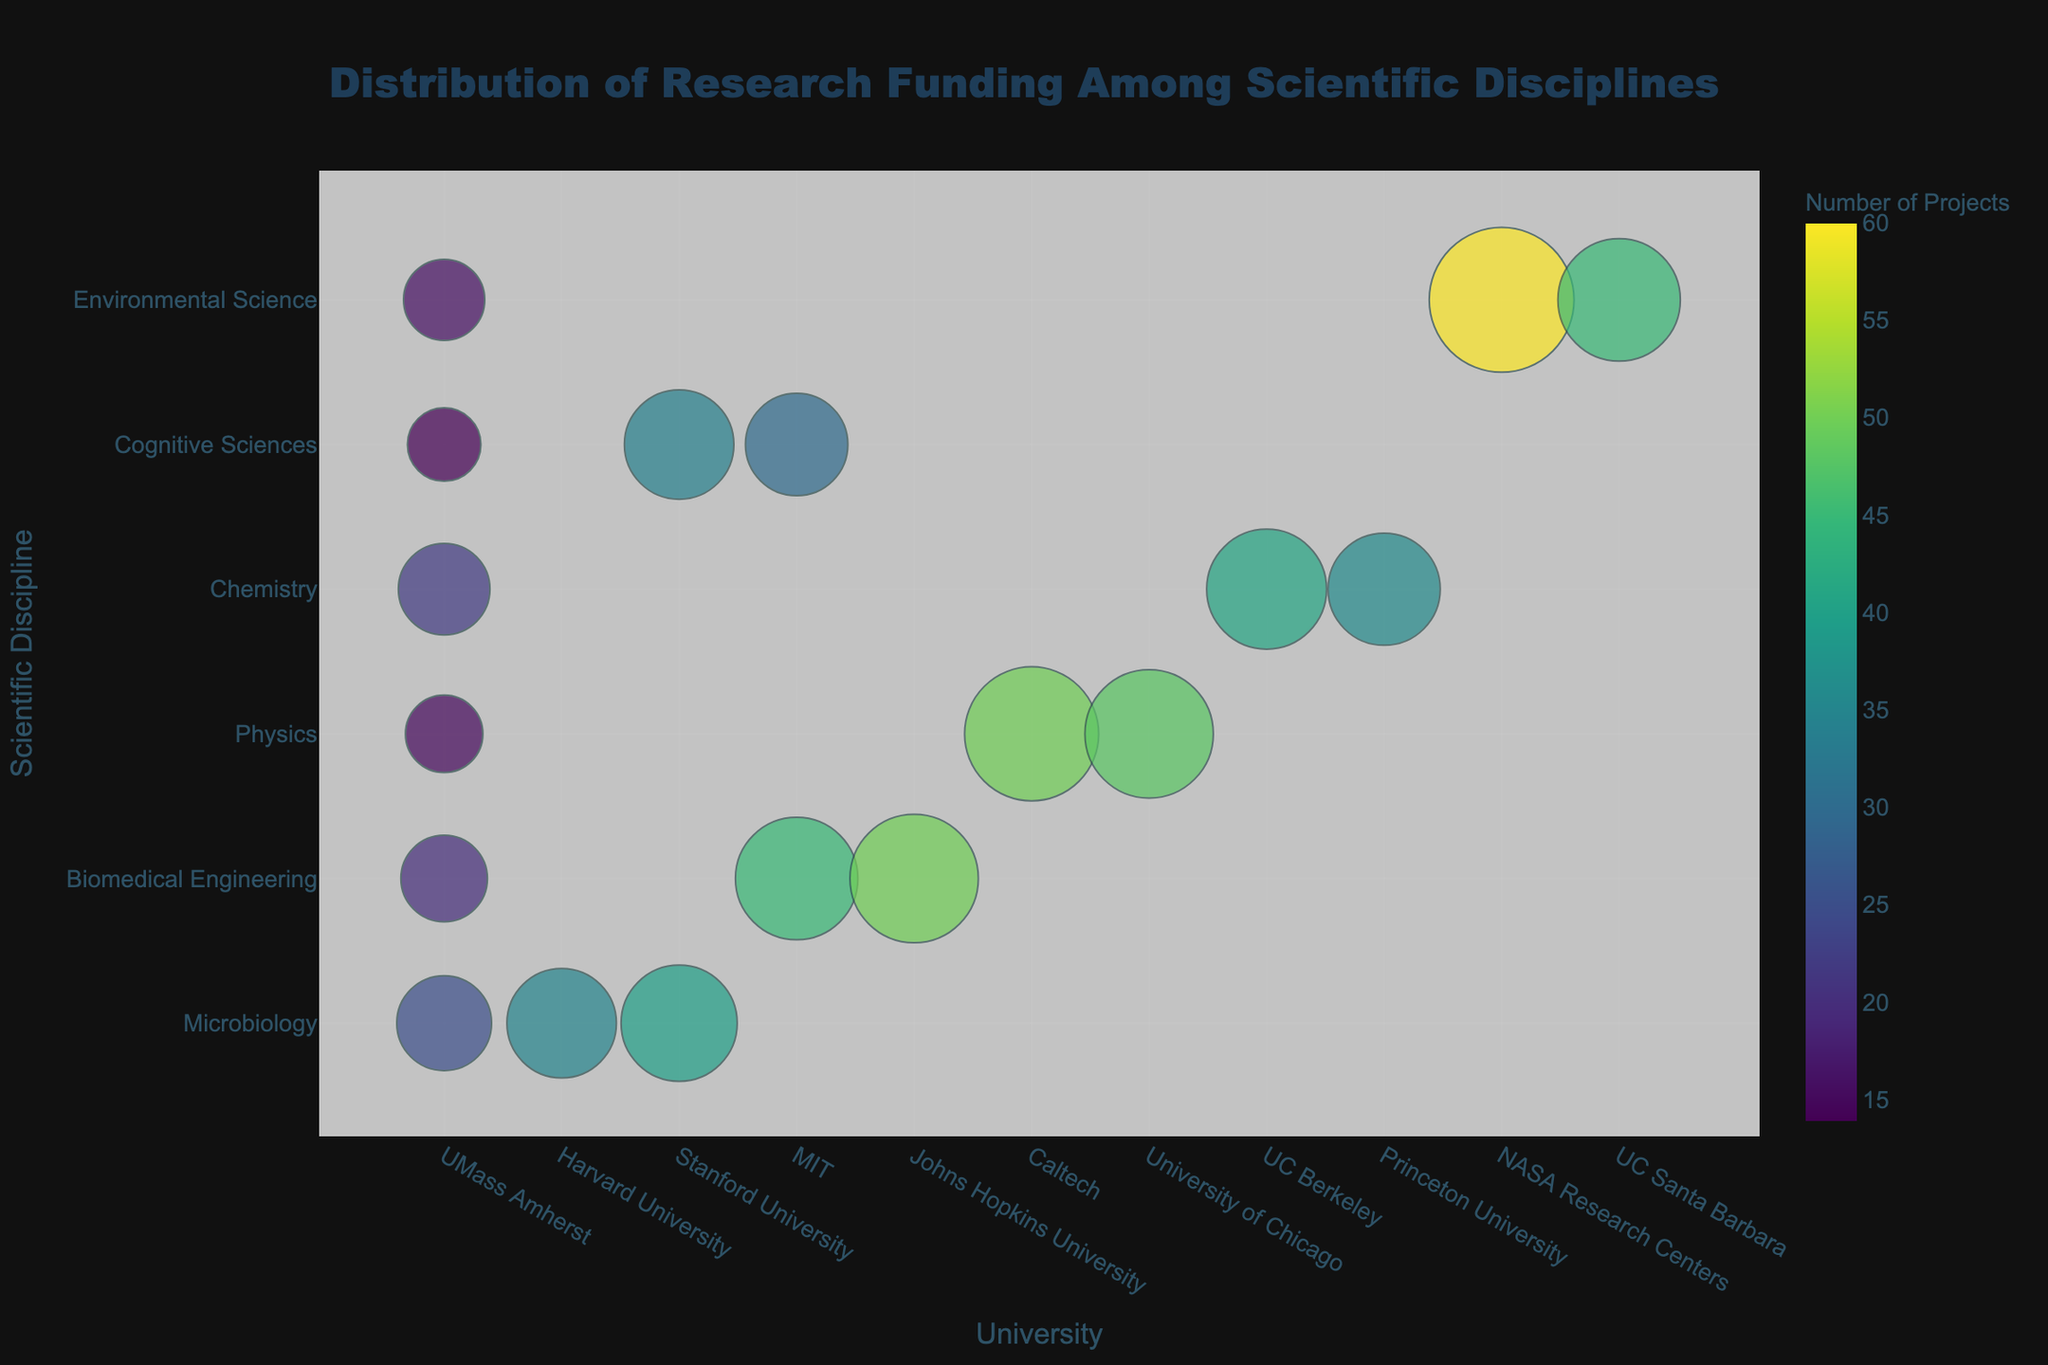Which university has the highest research funding in the Environmental Science discipline? By looking at the bubbles sorted by size in the Environmental Science row, the largest bubble corresponds to NASA Research Centers, indicating the highest funding.
Answer: NASA Research Centers Which discipline has the smallest total number of projects at UMass Amherst? To find this, add up the number of projects for each discipline at UMass Amherst: Microbiology (25), Biomedical Engineering (20), Physics (15), Chemistry (22), Cognitive Sciences (14), and Environmental Science (16). The smallest number is 14 in Cognitive Sciences.
Answer: Cognitive Sciences Among the universities listed, which one has the highest number of projects in the Physics discipline? By looking at the Physics row and comparing the "Number of Projects" colors, Caltech has the bubble with the darkest shade, indicating the highest number of projects.
Answer: Caltech Which university receives a noticeably larger amount of funding for Chemistry compared to other universities? By comparing the bubble sizes in the Chemistry row, UC Berkeley has a larger bubble size compared to Princeton University and UMass Amherst, indicating higher funding.
Answer: UC Berkeley How does the research funding for Microbiology at Stanford University compare to Harvard University? Compare the size of the bubbles for Microbiology at Stanford University and Harvard University. Stanford University has a slightly larger bubble (45 million) compared to Harvard University (40 million), indicating higher funding.
Answer: Stanford University has higher funding What's the average amount of research funding for Biomedical Engineering across the universities listed? Sum the funding amounts: UMass Amherst (25 million), MIT (50 million), and Johns Hopkins University (55 million). Then divide by the number of universities: (25 + 50 + 55) / 3 = 130 / 3 = ~43.33 million.
Answer: ~43.33 million Which university is an outlier in terms of the number of projects for the Environmental Science discipline? By examining the number of projects indicated by the color intensity, NASA Research Centers appear as an outlier with a significantly darker bubble in the Environmental Science row, indicating much higher numbers of projects relative to UC Santa Barbara and UMass Amherst.
Answer: NASA Research Centers Comparatively, which discipline has more consistent research funding levels across all universities: Chemistry or Physics? By observing the bubble sizes in the Chemistry and Physics rows, Chemistry bubbles are more consistent in size compared to the disparity between the largest (Caltech) and smallest (UMass Amherst) bubbles in the Physics row.
Answer: Chemistry Among the disciplines listed, which one has the highest diversity in research funding across different universities? This can be determined by observing the varying bubble sizes across each row: Environmental Science shows significant variability with NASA Research Centers having a much larger bubble compared to other universities.
Answer: Environmental Science 